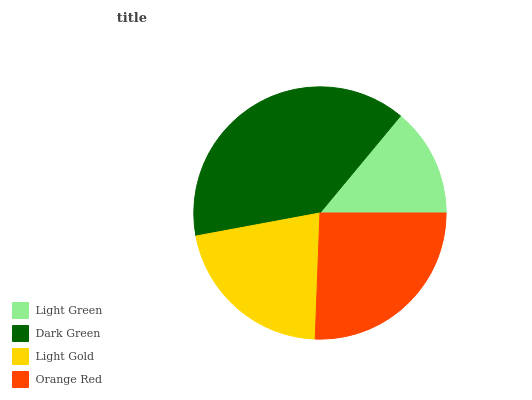Is Light Green the minimum?
Answer yes or no. Yes. Is Dark Green the maximum?
Answer yes or no. Yes. Is Light Gold the minimum?
Answer yes or no. No. Is Light Gold the maximum?
Answer yes or no. No. Is Dark Green greater than Light Gold?
Answer yes or no. Yes. Is Light Gold less than Dark Green?
Answer yes or no. Yes. Is Light Gold greater than Dark Green?
Answer yes or no. No. Is Dark Green less than Light Gold?
Answer yes or no. No. Is Orange Red the high median?
Answer yes or no. Yes. Is Light Gold the low median?
Answer yes or no. Yes. Is Light Green the high median?
Answer yes or no. No. Is Light Green the low median?
Answer yes or no. No. 